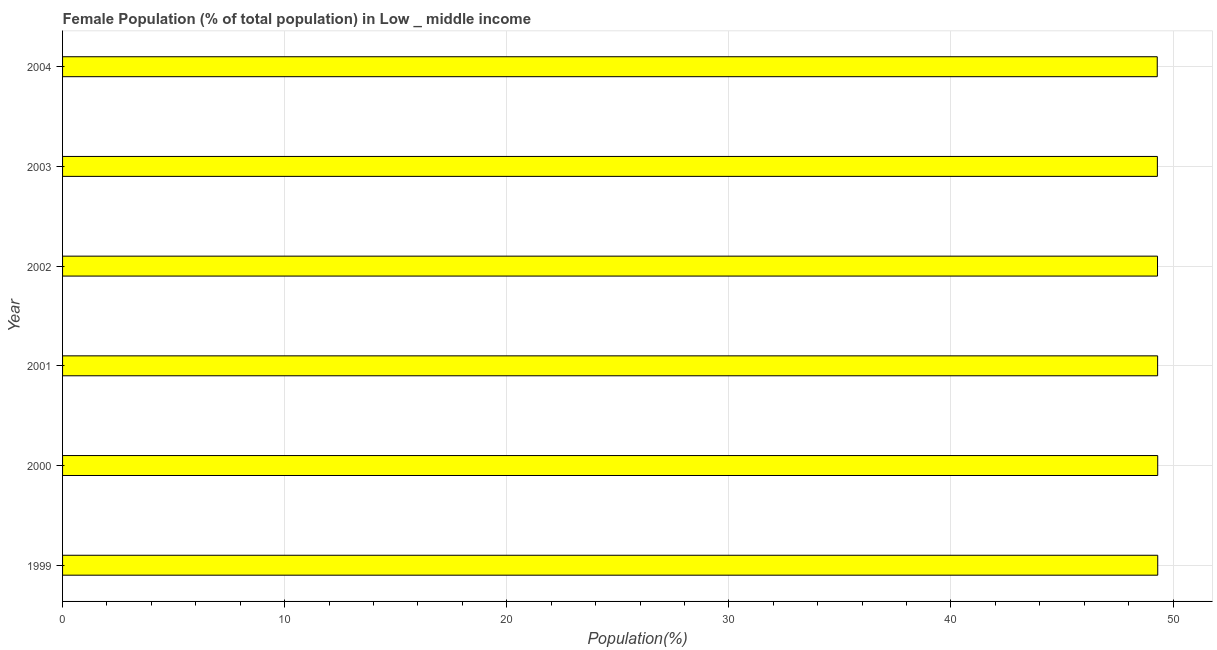Does the graph contain any zero values?
Give a very brief answer. No. Does the graph contain grids?
Offer a very short reply. Yes. What is the title of the graph?
Your response must be concise. Female Population (% of total population) in Low _ middle income. What is the label or title of the X-axis?
Your answer should be compact. Population(%). What is the label or title of the Y-axis?
Offer a very short reply. Year. What is the female population in 2004?
Your response must be concise. 49.29. Across all years, what is the maximum female population?
Your answer should be very brief. 49.31. Across all years, what is the minimum female population?
Keep it short and to the point. 49.29. What is the sum of the female population?
Ensure brevity in your answer.  295.8. What is the difference between the female population in 1999 and 2002?
Keep it short and to the point. 0.01. What is the average female population per year?
Provide a short and direct response. 49.3. What is the median female population?
Make the answer very short. 49.3. In how many years, is the female population greater than 38 %?
Your response must be concise. 6. Is the difference between the female population in 1999 and 2000 greater than the difference between any two years?
Offer a very short reply. No. What is the difference between the highest and the second highest female population?
Give a very brief answer. 0. What is the difference between the highest and the lowest female population?
Your response must be concise. 0.02. How many years are there in the graph?
Ensure brevity in your answer.  6. What is the difference between two consecutive major ticks on the X-axis?
Offer a very short reply. 10. What is the Population(%) in 1999?
Offer a very short reply. 49.31. What is the Population(%) of 2000?
Provide a short and direct response. 49.31. What is the Population(%) of 2001?
Make the answer very short. 49.3. What is the Population(%) in 2002?
Keep it short and to the point. 49.3. What is the Population(%) of 2003?
Your answer should be compact. 49.29. What is the Population(%) in 2004?
Keep it short and to the point. 49.29. What is the difference between the Population(%) in 1999 and 2000?
Your answer should be compact. 0. What is the difference between the Population(%) in 1999 and 2001?
Your answer should be very brief. 0. What is the difference between the Population(%) in 1999 and 2002?
Your answer should be compact. 0.01. What is the difference between the Population(%) in 1999 and 2003?
Your answer should be compact. 0.02. What is the difference between the Population(%) in 1999 and 2004?
Ensure brevity in your answer.  0.02. What is the difference between the Population(%) in 2000 and 2001?
Keep it short and to the point. 0. What is the difference between the Population(%) in 2000 and 2002?
Provide a succinct answer. 0.01. What is the difference between the Population(%) in 2000 and 2003?
Your answer should be compact. 0.02. What is the difference between the Population(%) in 2000 and 2004?
Ensure brevity in your answer.  0.02. What is the difference between the Population(%) in 2001 and 2002?
Offer a terse response. 0.01. What is the difference between the Population(%) in 2001 and 2003?
Give a very brief answer. 0.01. What is the difference between the Population(%) in 2001 and 2004?
Keep it short and to the point. 0.02. What is the difference between the Population(%) in 2002 and 2003?
Keep it short and to the point. 0.01. What is the difference between the Population(%) in 2002 and 2004?
Provide a succinct answer. 0.01. What is the difference between the Population(%) in 2003 and 2004?
Offer a very short reply. 0.01. What is the ratio of the Population(%) in 1999 to that in 2000?
Keep it short and to the point. 1. What is the ratio of the Population(%) in 2000 to that in 2003?
Make the answer very short. 1. What is the ratio of the Population(%) in 2000 to that in 2004?
Offer a terse response. 1. What is the ratio of the Population(%) in 2001 to that in 2002?
Ensure brevity in your answer.  1. 